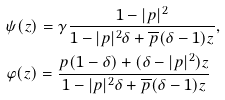Convert formula to latex. <formula><loc_0><loc_0><loc_500><loc_500>& \psi ( z ) = \gamma \frac { 1 - | p | ^ { 2 } } { 1 - | p | ^ { 2 } \delta + \overline { p } ( \delta - 1 ) z } , \\ & \varphi ( z ) = \frac { p ( 1 - \delta ) + ( \delta - | p | ^ { 2 } ) z } { 1 - | p | ^ { 2 } \delta + \overline { p } ( \delta - 1 ) z }</formula> 